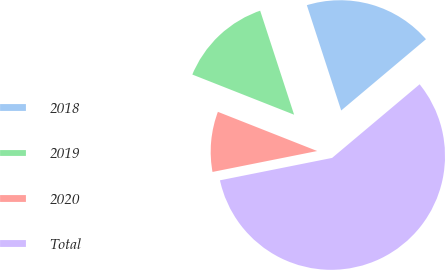Convert chart to OTSL. <chart><loc_0><loc_0><loc_500><loc_500><pie_chart><fcel>2018<fcel>2019<fcel>2020<fcel>Total<nl><fcel>18.89%<fcel>14.0%<fcel>9.12%<fcel>57.99%<nl></chart> 